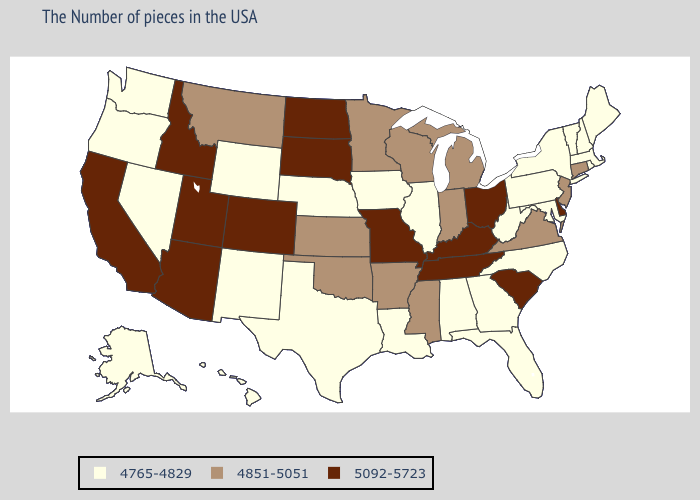Name the states that have a value in the range 5092-5723?
Give a very brief answer. Delaware, South Carolina, Ohio, Kentucky, Tennessee, Missouri, South Dakota, North Dakota, Colorado, Utah, Arizona, Idaho, California. Does the first symbol in the legend represent the smallest category?
Keep it brief. Yes. Does Wisconsin have a higher value than Montana?
Short answer required. No. What is the value of Minnesota?
Answer briefly. 4851-5051. Which states have the lowest value in the MidWest?
Keep it brief. Illinois, Iowa, Nebraska. What is the highest value in the USA?
Keep it brief. 5092-5723. Does the first symbol in the legend represent the smallest category?
Give a very brief answer. Yes. What is the highest value in the MidWest ?
Be succinct. 5092-5723. What is the value of Colorado?
Keep it brief. 5092-5723. What is the lowest value in the South?
Quick response, please. 4765-4829. What is the lowest value in states that border Vermont?
Be succinct. 4765-4829. Is the legend a continuous bar?
Quick response, please. No. Among the states that border Louisiana , which have the lowest value?
Keep it brief. Texas. Is the legend a continuous bar?
Answer briefly. No. Which states have the lowest value in the USA?
Give a very brief answer. Maine, Massachusetts, Rhode Island, New Hampshire, Vermont, New York, Maryland, Pennsylvania, North Carolina, West Virginia, Florida, Georgia, Alabama, Illinois, Louisiana, Iowa, Nebraska, Texas, Wyoming, New Mexico, Nevada, Washington, Oregon, Alaska, Hawaii. 